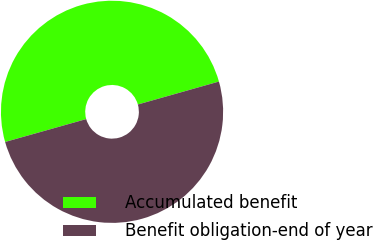Convert chart to OTSL. <chart><loc_0><loc_0><loc_500><loc_500><pie_chart><fcel>Accumulated benefit<fcel>Benefit obligation-end of year<nl><fcel>49.99%<fcel>50.01%<nl></chart> 